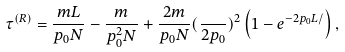Convert formula to latex. <formula><loc_0><loc_0><loc_500><loc_500>\tau ^ { ( R ) } = \frac { m L } { p _ { 0 } N } - \frac { m } { p _ { 0 } ^ { 2 } N } + \frac { 2 m } { p _ { 0 } N } ( \frac { } { 2 p _ { 0 } } ) ^ { 2 } \left ( 1 - e ^ { - 2 p _ { 0 } L / } \right ) ,</formula> 